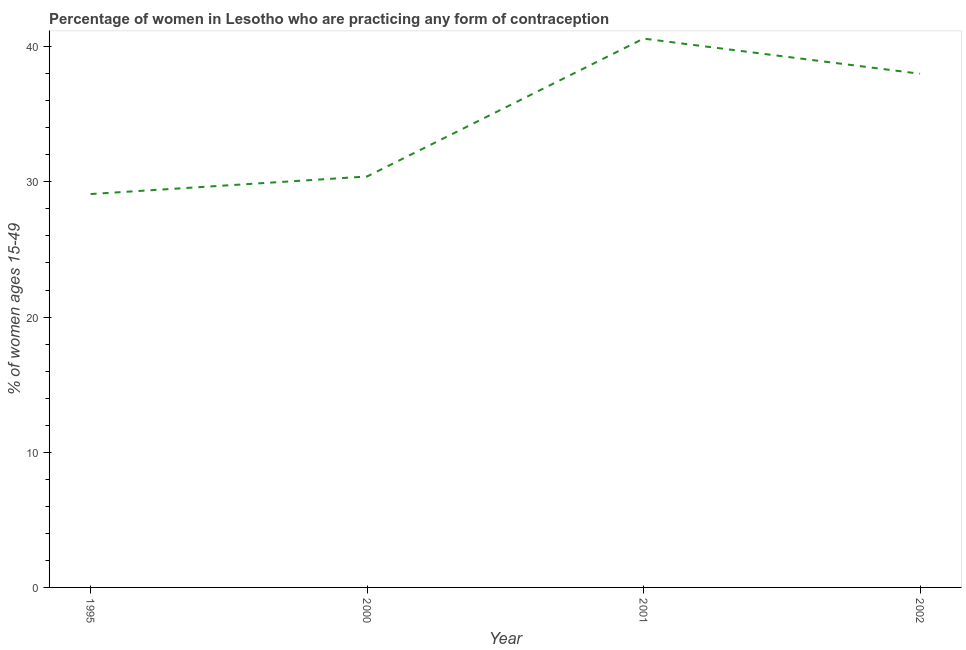What is the contraceptive prevalence in 2000?
Ensure brevity in your answer.  30.4. Across all years, what is the maximum contraceptive prevalence?
Your answer should be compact. 40.6. Across all years, what is the minimum contraceptive prevalence?
Offer a terse response. 29.1. What is the sum of the contraceptive prevalence?
Your answer should be very brief. 138.1. What is the difference between the contraceptive prevalence in 1995 and 2000?
Your response must be concise. -1.3. What is the average contraceptive prevalence per year?
Offer a very short reply. 34.52. What is the median contraceptive prevalence?
Offer a terse response. 34.2. In how many years, is the contraceptive prevalence greater than 14 %?
Ensure brevity in your answer.  4. What is the ratio of the contraceptive prevalence in 1995 to that in 2001?
Give a very brief answer. 0.72. Is the difference between the contraceptive prevalence in 1995 and 2001 greater than the difference between any two years?
Give a very brief answer. Yes. What is the difference between the highest and the second highest contraceptive prevalence?
Provide a succinct answer. 2.6. What is the difference between the highest and the lowest contraceptive prevalence?
Keep it short and to the point. 11.5. Does the graph contain any zero values?
Your answer should be very brief. No. Does the graph contain grids?
Offer a terse response. No. What is the title of the graph?
Keep it short and to the point. Percentage of women in Lesotho who are practicing any form of contraception. What is the label or title of the X-axis?
Your response must be concise. Year. What is the label or title of the Y-axis?
Give a very brief answer. % of women ages 15-49. What is the % of women ages 15-49 of 1995?
Offer a very short reply. 29.1. What is the % of women ages 15-49 in 2000?
Give a very brief answer. 30.4. What is the % of women ages 15-49 of 2001?
Give a very brief answer. 40.6. What is the % of women ages 15-49 of 2002?
Give a very brief answer. 38. What is the difference between the % of women ages 15-49 in 1995 and 2000?
Your answer should be very brief. -1.3. What is the difference between the % of women ages 15-49 in 1995 and 2001?
Offer a very short reply. -11.5. What is the difference between the % of women ages 15-49 in 1995 and 2002?
Ensure brevity in your answer.  -8.9. What is the difference between the % of women ages 15-49 in 2000 and 2002?
Provide a short and direct response. -7.6. What is the difference between the % of women ages 15-49 in 2001 and 2002?
Provide a short and direct response. 2.6. What is the ratio of the % of women ages 15-49 in 1995 to that in 2000?
Your answer should be compact. 0.96. What is the ratio of the % of women ages 15-49 in 1995 to that in 2001?
Give a very brief answer. 0.72. What is the ratio of the % of women ages 15-49 in 1995 to that in 2002?
Offer a very short reply. 0.77. What is the ratio of the % of women ages 15-49 in 2000 to that in 2001?
Your response must be concise. 0.75. What is the ratio of the % of women ages 15-49 in 2000 to that in 2002?
Make the answer very short. 0.8. What is the ratio of the % of women ages 15-49 in 2001 to that in 2002?
Give a very brief answer. 1.07. 